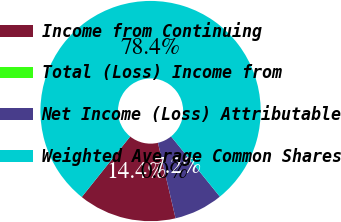Convert chart. <chart><loc_0><loc_0><loc_500><loc_500><pie_chart><fcel>Income from Continuing<fcel>Total (Loss) Income from<fcel>Net Income (Loss) Attributable<fcel>Weighted Average Common Shares<nl><fcel>14.39%<fcel>0.0%<fcel>7.19%<fcel>78.42%<nl></chart> 